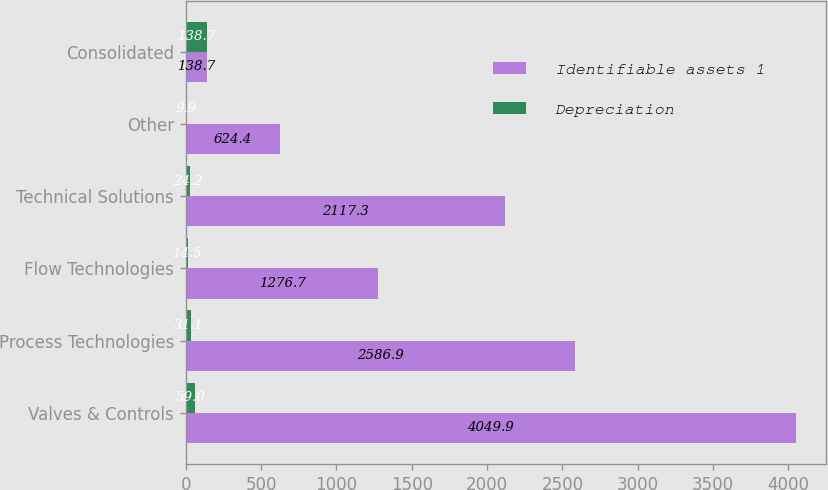Convert chart. <chart><loc_0><loc_0><loc_500><loc_500><stacked_bar_chart><ecel><fcel>Valves & Controls<fcel>Process Technologies<fcel>Flow Technologies<fcel>Technical Solutions<fcel>Other<fcel>Consolidated<nl><fcel>Identifiable assets 1<fcel>4049.9<fcel>2586.9<fcel>1276.7<fcel>2117.3<fcel>624.4<fcel>138.7<nl><fcel>Depreciation<fcel>59<fcel>31.1<fcel>14.5<fcel>24.2<fcel>9.9<fcel>138.7<nl></chart> 